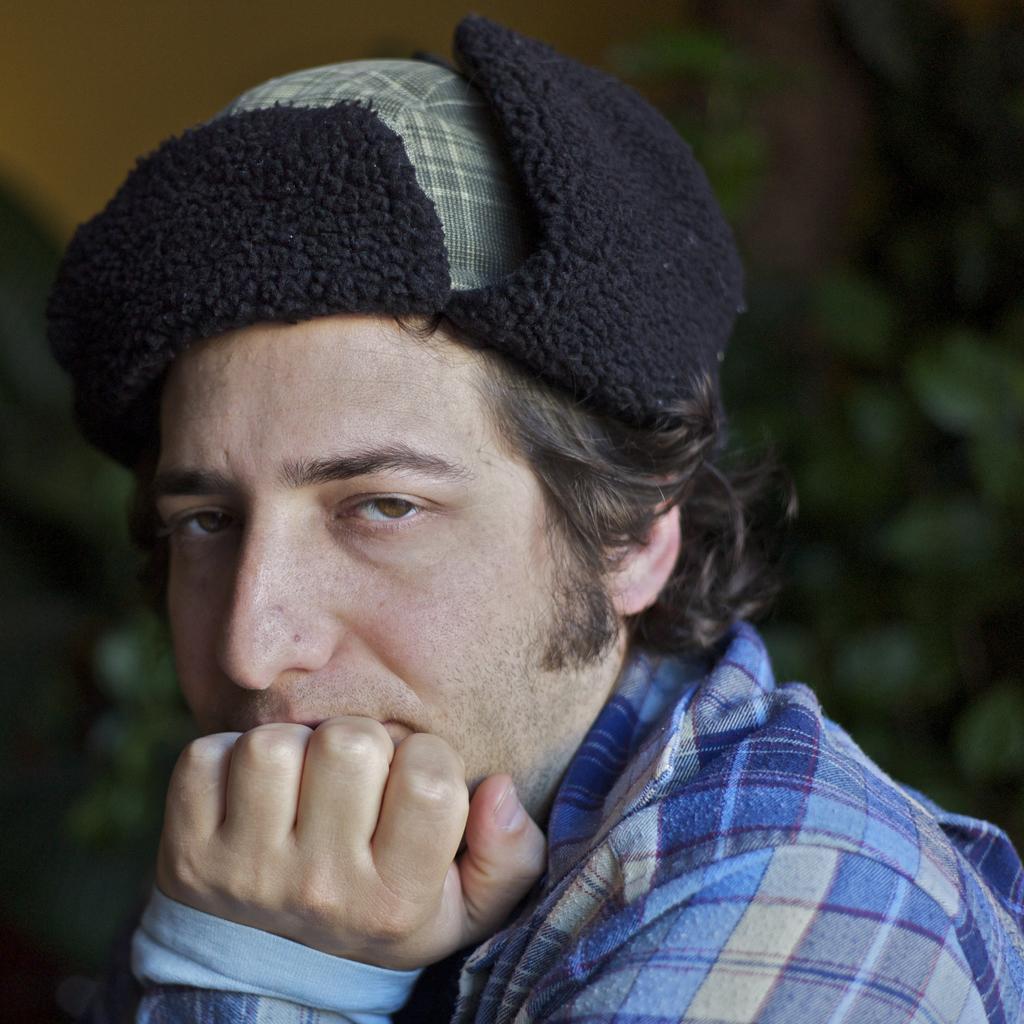Describe this image in one or two sentences. In this image we can see a person wearing a dress and a cap. 